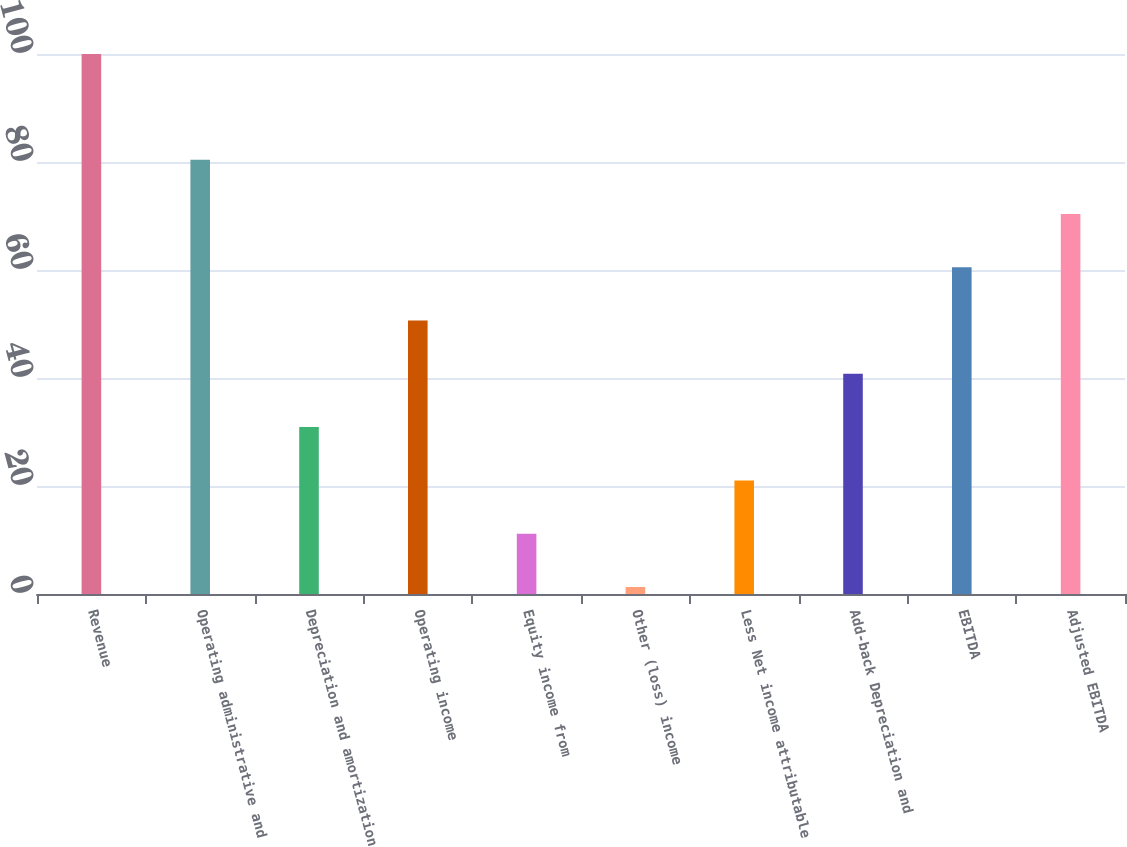Convert chart. <chart><loc_0><loc_0><loc_500><loc_500><bar_chart><fcel>Revenue<fcel>Operating administrative and<fcel>Depreciation and amortization<fcel>Operating income<fcel>Equity income from<fcel>Other (loss) income<fcel>Less Net income attributable<fcel>Add-back Depreciation and<fcel>EBITDA<fcel>Adjusted EBITDA<nl><fcel>100<fcel>80.4<fcel>30.91<fcel>50.65<fcel>11.17<fcel>1.3<fcel>21.04<fcel>40.78<fcel>60.52<fcel>70.39<nl></chart> 